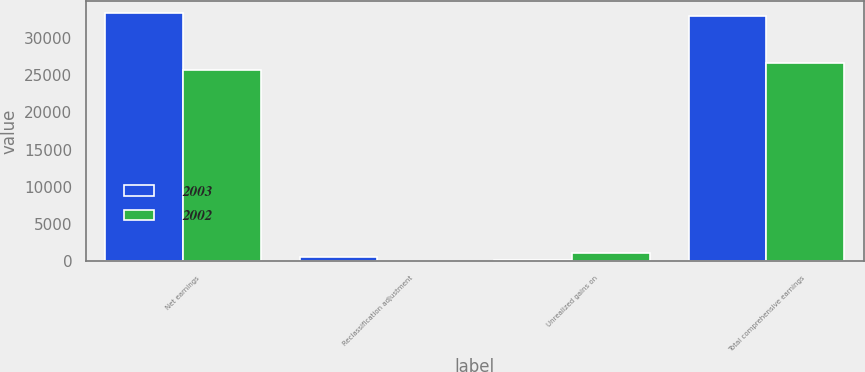Convert chart. <chart><loc_0><loc_0><loc_500><loc_500><stacked_bar_chart><ecel><fcel>Net earnings<fcel>Reclassification adjustment<fcel>Unrealized gains on<fcel>Total comprehensive earnings<nl><fcel>2003<fcel>33270<fcel>529<fcel>182<fcel>32923<nl><fcel>2002<fcel>25621<fcel>116<fcel>1068<fcel>26573<nl></chart> 